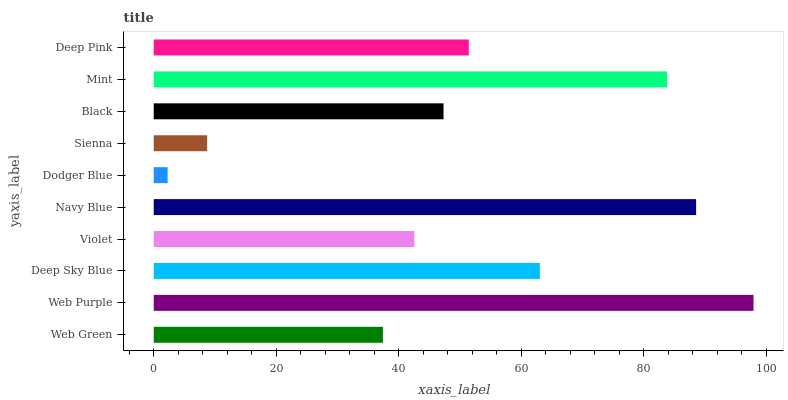Is Dodger Blue the minimum?
Answer yes or no. Yes. Is Web Purple the maximum?
Answer yes or no. Yes. Is Deep Sky Blue the minimum?
Answer yes or no. No. Is Deep Sky Blue the maximum?
Answer yes or no. No. Is Web Purple greater than Deep Sky Blue?
Answer yes or no. Yes. Is Deep Sky Blue less than Web Purple?
Answer yes or no. Yes. Is Deep Sky Blue greater than Web Purple?
Answer yes or no. No. Is Web Purple less than Deep Sky Blue?
Answer yes or no. No. Is Deep Pink the high median?
Answer yes or no. Yes. Is Black the low median?
Answer yes or no. Yes. Is Mint the high median?
Answer yes or no. No. Is Deep Pink the low median?
Answer yes or no. No. 